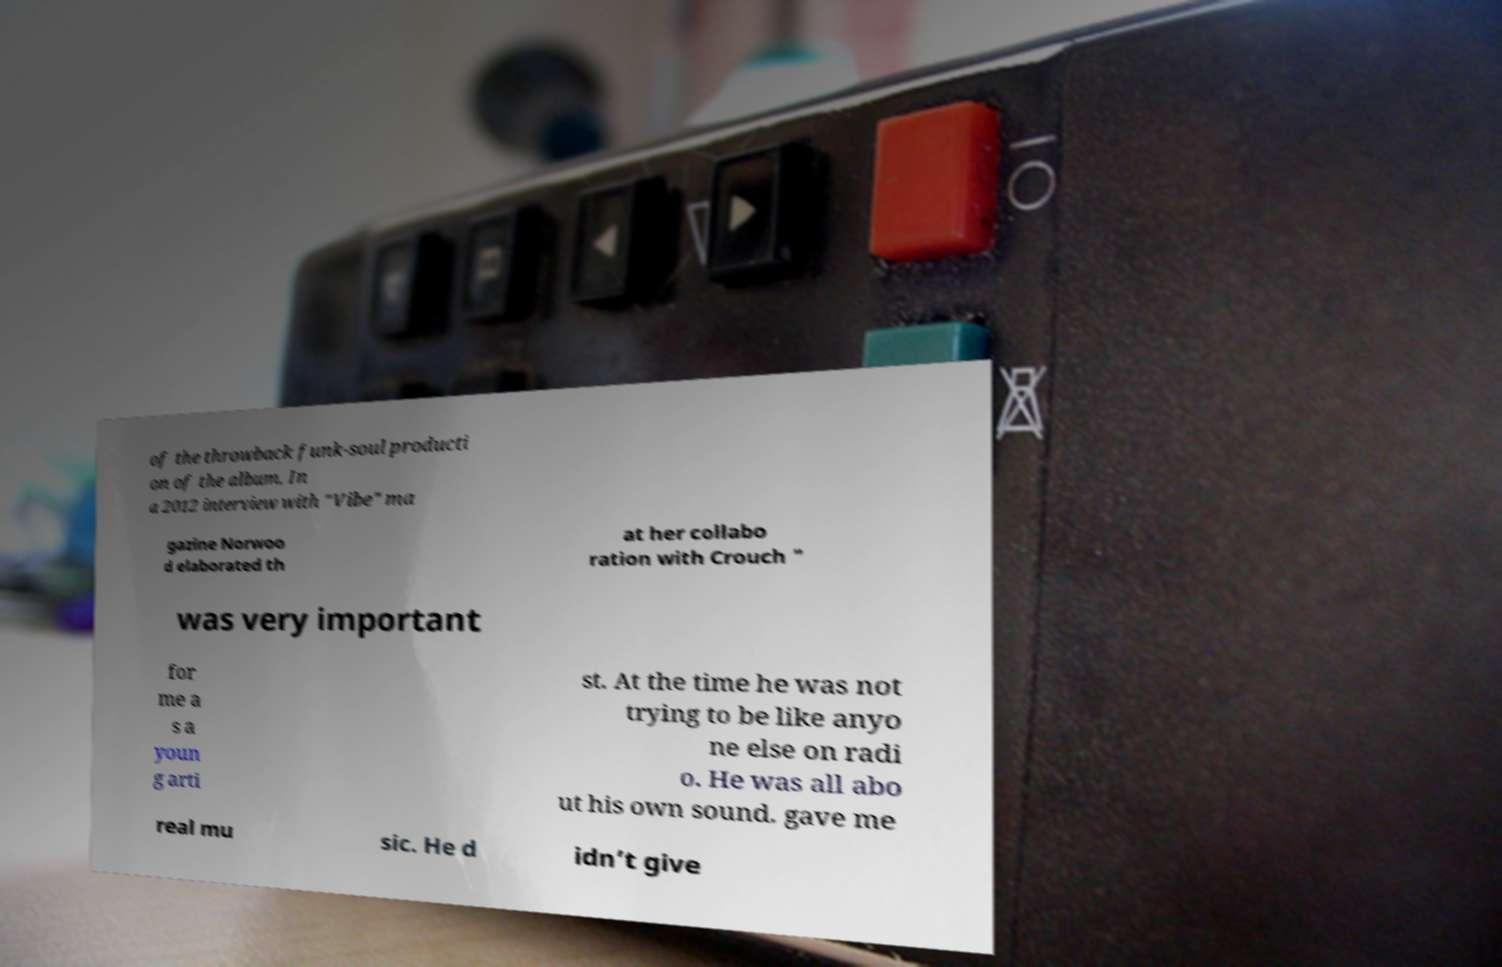Please identify and transcribe the text found in this image. of the throwback funk-soul producti on of the album. In a 2012 interview with "Vibe" ma gazine Norwoo d elaborated th at her collabo ration with Crouch " was very important for me a s a youn g arti st. At the time he was not trying to be like anyo ne else on radi o. He was all abo ut his own sound. gave me real mu sic. He d idn’t give 